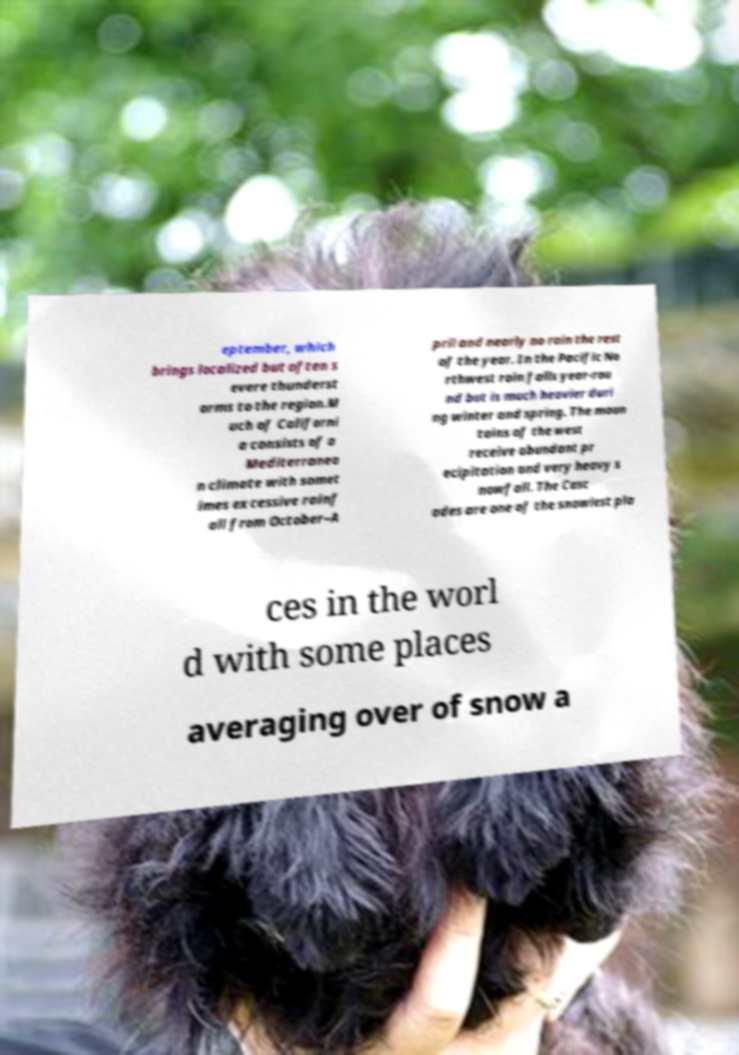Could you extract and type out the text from this image? eptember, which brings localized but often s evere thunderst orms to the region.M uch of Californi a consists of a Mediterranea n climate with somet imes excessive rainf all from October–A pril and nearly no rain the rest of the year. In the Pacific No rthwest rain falls year-rou nd but is much heavier duri ng winter and spring. The moun tains of the west receive abundant pr ecipitation and very heavy s nowfall. The Casc ades are one of the snowiest pla ces in the worl d with some places averaging over of snow a 